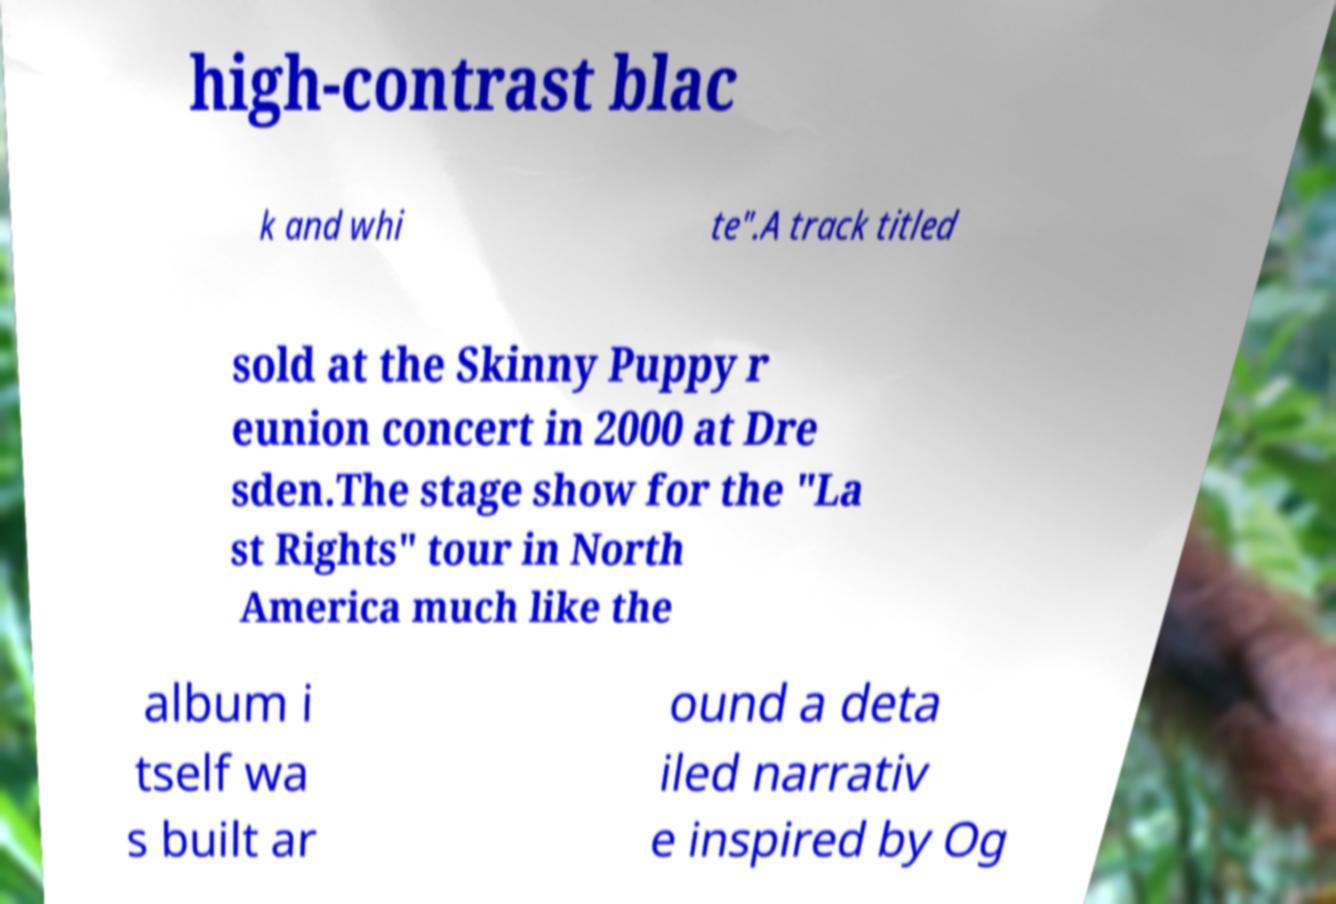Could you extract and type out the text from this image? high-contrast blac k and whi te".A track titled sold at the Skinny Puppy r eunion concert in 2000 at Dre sden.The stage show for the "La st Rights" tour in North America much like the album i tself wa s built ar ound a deta iled narrativ e inspired by Og 